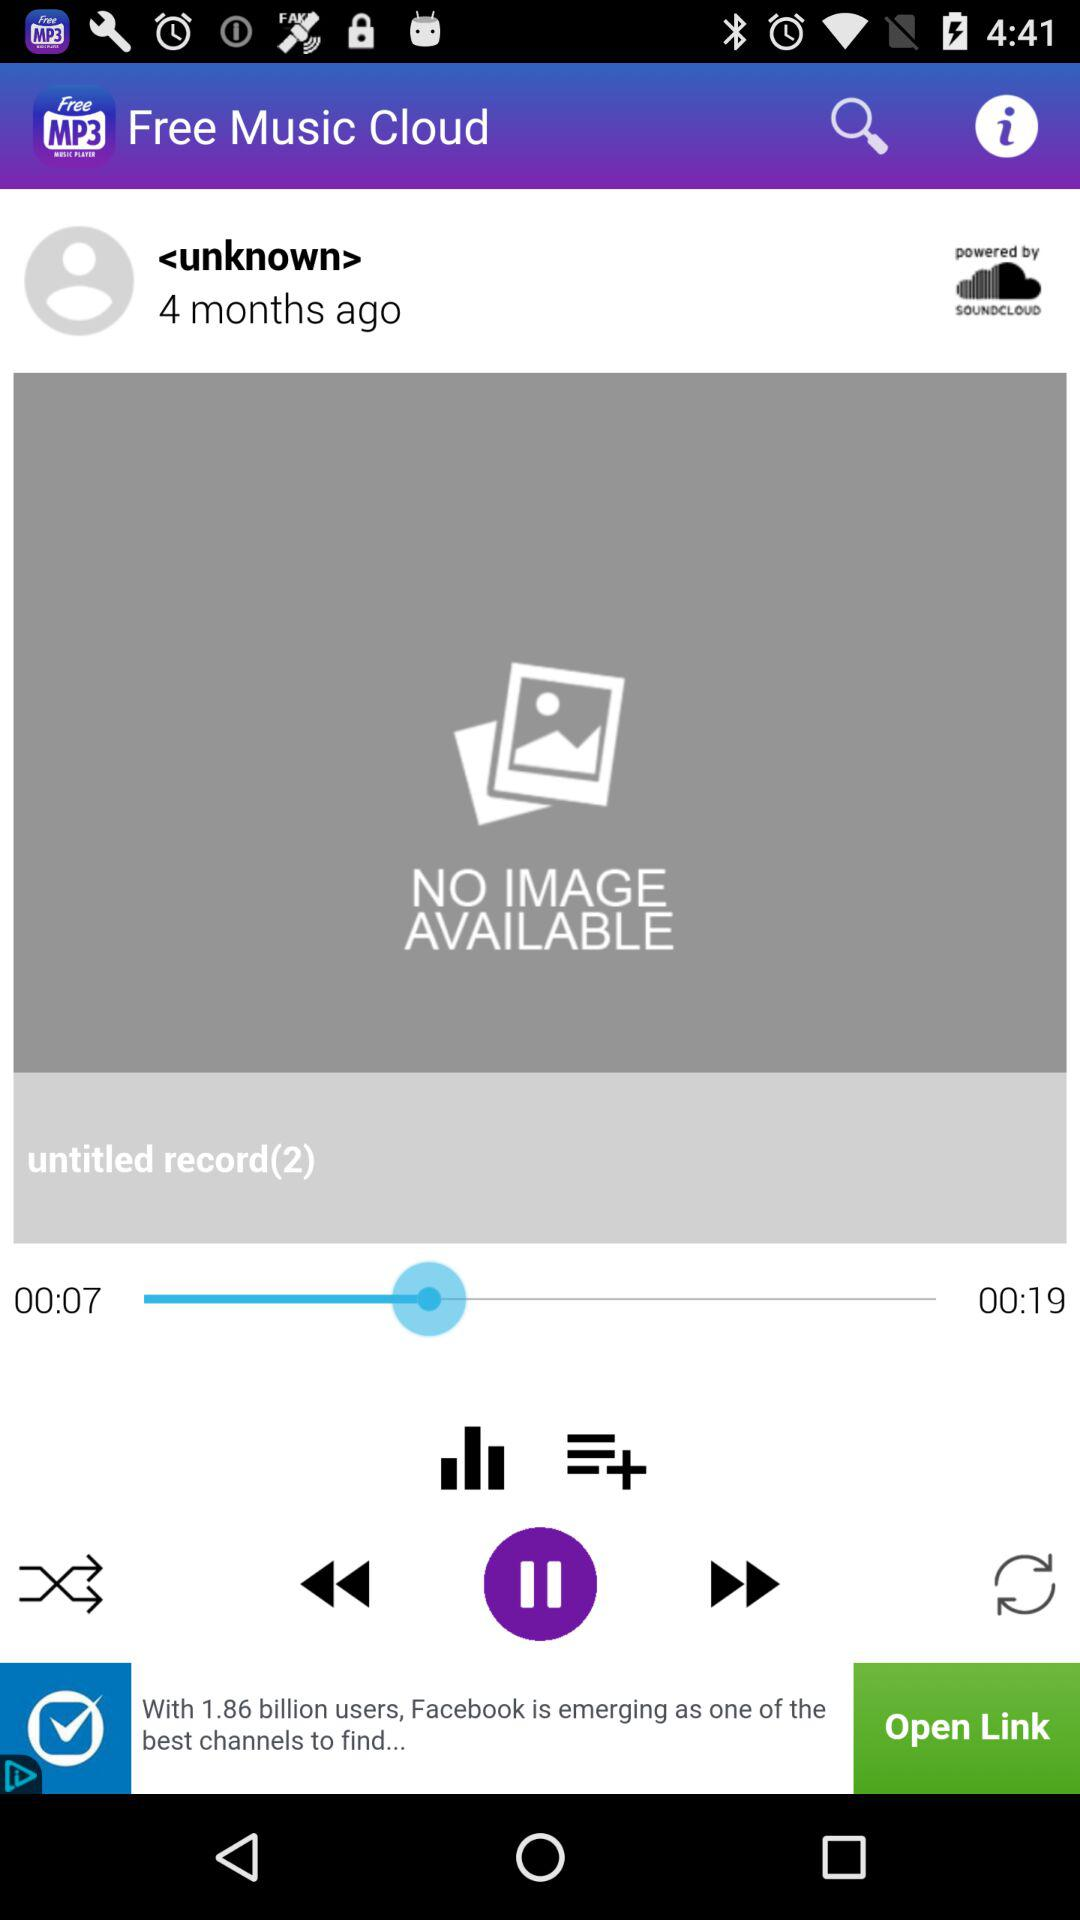What is the total time of the "untitled record(2)"? The total time of the "untitled record(2)" is 19 seconds. 